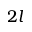<formula> <loc_0><loc_0><loc_500><loc_500>2 l</formula> 